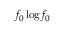<formula> <loc_0><loc_0><loc_500><loc_500>f _ { 0 } \log f _ { 0 }</formula> 